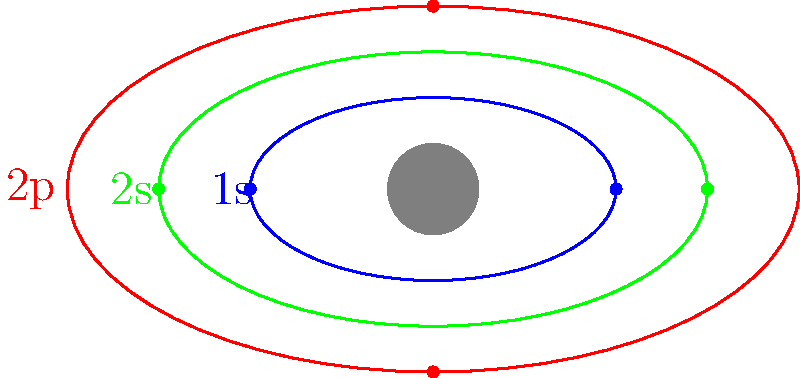In the atomic model shown, which orbital corresponds to the highest energy level, and how many electrons are depicted in this orbital? To answer this question, we need to analyze the electron orbitals depicted in the illustration:

1. The diagram shows three distinct orbitals, represented by ellipses of different colors and sizes.

2. In atomic physics, the energy level of an orbital increases with its distance from the nucleus. Therefore, the outermost orbital represents the highest energy level.

3. The orbitals are labeled as follows:
   - Blue (innermost): 1s orbital
   - Green (middle): 2s orbital
   - Red (outermost): 2p orbital

4. The 2p orbital, being the outermost, corresponds to the highest energy level among those shown.

5. To determine the number of electrons in the 2p orbital, we count the dots (representing electrons) on the red ellipse.

6. There are two dots on the red ellipse, one at the top and one at the bottom.

Therefore, the 2p orbital is the highest energy level shown, and it contains 2 electrons.
Answer: 2p orbital, 2 electrons 